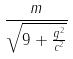<formula> <loc_0><loc_0><loc_500><loc_500>\frac { m } { \sqrt { 9 + \frac { g ^ { 2 } } { c ^ { 2 } } } }</formula> 